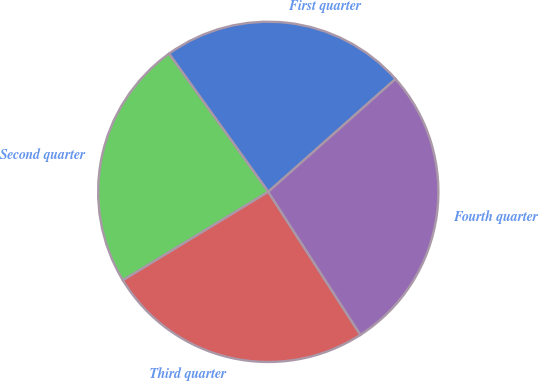Convert chart. <chart><loc_0><loc_0><loc_500><loc_500><pie_chart><fcel>First quarter<fcel>Second quarter<fcel>Third quarter<fcel>Fourth quarter<nl><fcel>23.37%<fcel>23.78%<fcel>25.41%<fcel>27.43%<nl></chart> 